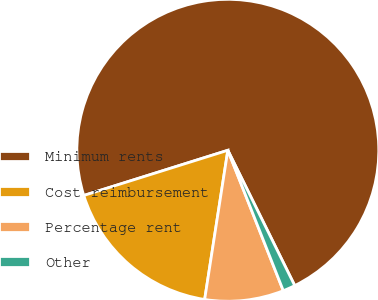Convert chart to OTSL. <chart><loc_0><loc_0><loc_500><loc_500><pie_chart><fcel>Minimum rents<fcel>Cost reimbursement<fcel>Percentage rent<fcel>Other<nl><fcel>72.53%<fcel>17.71%<fcel>8.44%<fcel>1.32%<nl></chart> 